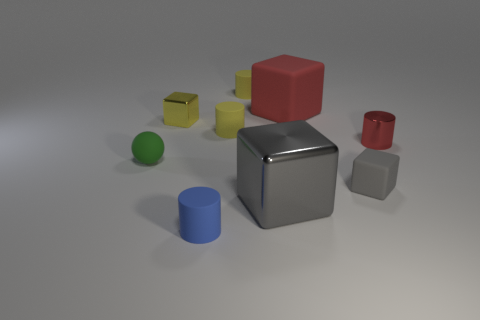Are there fewer yellow cubes that are behind the big red matte object than big red blocks on the left side of the small green sphere?
Provide a succinct answer. No. What color is the rubber object in front of the tiny gray cube?
Offer a terse response. Blue. What number of other objects are there of the same color as the small ball?
Your answer should be very brief. 0. There is a metal cube behind the matte sphere; is it the same size as the small red metal cylinder?
Provide a succinct answer. Yes. There is a blue cylinder; what number of tiny green matte balls are to the left of it?
Provide a short and direct response. 1. Is there a red rubber cylinder that has the same size as the yellow block?
Offer a very short reply. No. Do the small rubber block and the large rubber cube have the same color?
Your answer should be compact. No. What color is the large object that is in front of the tiny gray thing that is on the right side of the blue matte cylinder?
Ensure brevity in your answer.  Gray. How many cylinders are to the left of the gray rubber object and behind the green ball?
Your response must be concise. 2. What number of other tiny shiny objects have the same shape as the small red thing?
Keep it short and to the point. 0. 